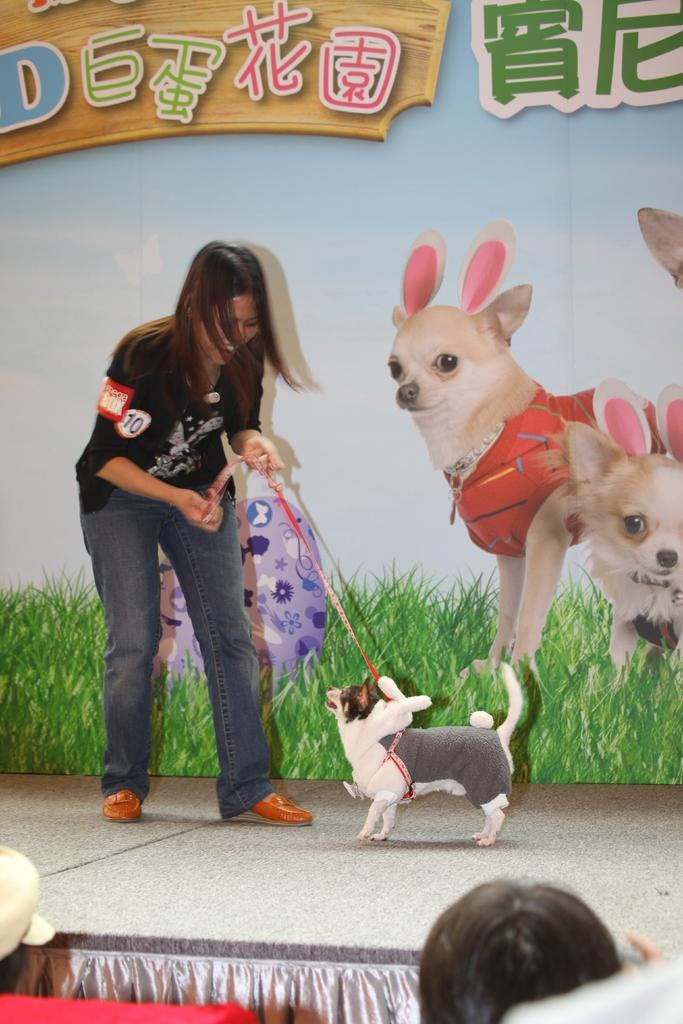Who is present in the image? There is a woman in the image. What is the woman doing in the image? The woman is standing and smiling in the image. What is the woman holding in the image? The woman is holding a rope in the image. What is the rope connected to? The rope is tied to a dog in the image. What can be seen in the background of the image? There is a picture of two dogs in the background. What type of instrument is the woman playing in the image? There is no instrument present in the image; the woman is holding a rope tied to a dog. What kind of shade is covering the woman in the image? There is no shade covering the woman in the image; she is standing in an open area. 